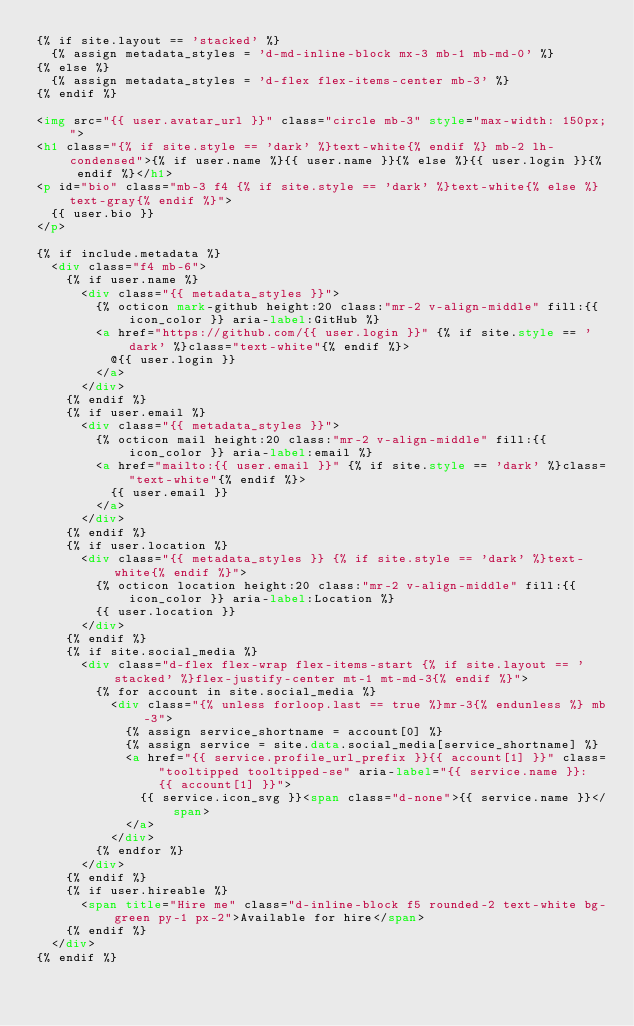<code> <loc_0><loc_0><loc_500><loc_500><_HTML_>{% if site.layout == 'stacked' %}
  {% assign metadata_styles = 'd-md-inline-block mx-3 mb-1 mb-md-0' %}
{% else %}
  {% assign metadata_styles = 'd-flex flex-items-center mb-3' %}
{% endif %}

<img src="{{ user.avatar_url }}" class="circle mb-3" style="max-width: 150px;">
<h1 class="{% if site.style == 'dark' %}text-white{% endif %} mb-2 lh-condensed">{% if user.name %}{{ user.name }}{% else %}{{ user.login }}{% endif %}</h1>
<p id="bio" class="mb-3 f4 {% if site.style == 'dark' %}text-white{% else %}text-gray{% endif %}">
  {{ user.bio }}
</p>

{% if include.metadata %}
  <div class="f4 mb-6">
    {% if user.name %}
      <div class="{{ metadata_styles }}">
        {% octicon mark-github height:20 class:"mr-2 v-align-middle" fill:{{ icon_color }} aria-label:GitHub %}
        <a href="https://github.com/{{ user.login }}" {% if site.style == 'dark' %}class="text-white"{% endif %}>
          @{{ user.login }}
        </a>
      </div>
    {% endif %}
    {% if user.email %}
      <div class="{{ metadata_styles }}">
        {% octicon mail height:20 class:"mr-2 v-align-middle" fill:{{ icon_color }} aria-label:email %}
        <a href="mailto:{{ user.email }}" {% if site.style == 'dark' %}class="text-white"{% endif %}>
          {{ user.email }}
        </a>
      </div>
    {% endif %}
    {% if user.location %}
      <div class="{{ metadata_styles }} {% if site.style == 'dark' %}text-white{% endif %}">
        {% octicon location height:20 class:"mr-2 v-align-middle" fill:{{ icon_color }} aria-label:Location %}
        {{ user.location }}
      </div>
    {% endif %}
    {% if site.social_media %}
      <div class="d-flex flex-wrap flex-items-start {% if site.layout == 'stacked' %}flex-justify-center mt-1 mt-md-3{% endif %}">
        {% for account in site.social_media %}
          <div class="{% unless forloop.last == true %}mr-3{% endunless %} mb-3">
            {% assign service_shortname = account[0] %}
            {% assign service = site.data.social_media[service_shortname] %}
            <a href="{{ service.profile_url_prefix }}{{ account[1] }}" class="tooltipped tooltipped-se" aria-label="{{ service.name }}: {{ account[1] }}">
              {{ service.icon_svg }}<span class="d-none">{{ service.name }}</span>
            </a>
          </div>
        {% endfor %}
      </div>
    {% endif %}
    {% if user.hireable %}
      <span title="Hire me" class="d-inline-block f5 rounded-2 text-white bg-green py-1 px-2">Available for hire</span>
    {% endif %}
  </div>
{% endif %}
</code> 